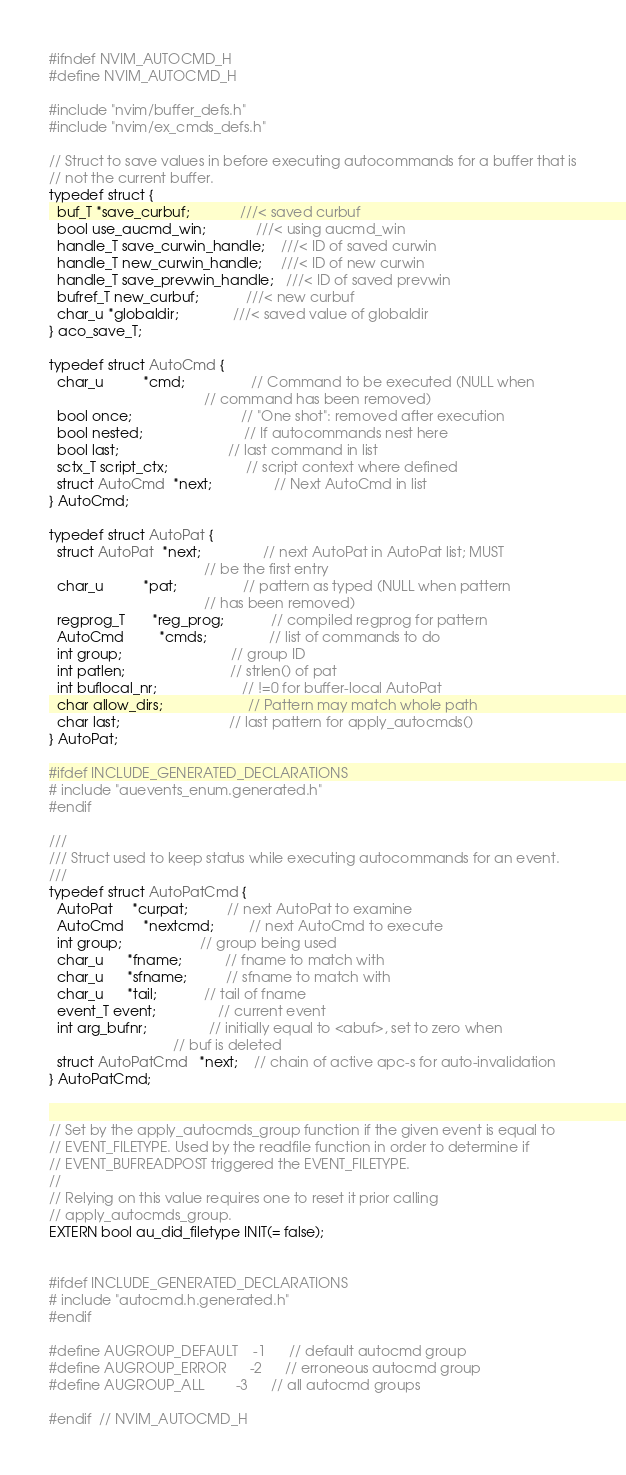<code> <loc_0><loc_0><loc_500><loc_500><_C_>#ifndef NVIM_AUTOCMD_H
#define NVIM_AUTOCMD_H

#include "nvim/buffer_defs.h"
#include "nvim/ex_cmds_defs.h"

// Struct to save values in before executing autocommands for a buffer that is
// not the current buffer.
typedef struct {
  buf_T *save_curbuf;             ///< saved curbuf
  bool use_aucmd_win;             ///< using aucmd_win
  handle_T save_curwin_handle;    ///< ID of saved curwin
  handle_T new_curwin_handle;     ///< ID of new curwin
  handle_T save_prevwin_handle;   ///< ID of saved prevwin
  bufref_T new_curbuf;            ///< new curbuf
  char_u *globaldir;              ///< saved value of globaldir
} aco_save_T;

typedef struct AutoCmd {
  char_u          *cmd;                 // Command to be executed (NULL when
                                        // command has been removed)
  bool once;                            // "One shot": removed after execution
  bool nested;                          // If autocommands nest here
  bool last;                            // last command in list
  sctx_T script_ctx;                    // script context where defined
  struct AutoCmd  *next;                // Next AutoCmd in list
} AutoCmd;

typedef struct AutoPat {
  struct AutoPat  *next;                // next AutoPat in AutoPat list; MUST
                                        // be the first entry
  char_u          *pat;                 // pattern as typed (NULL when pattern
                                        // has been removed)
  regprog_T       *reg_prog;            // compiled regprog for pattern
  AutoCmd         *cmds;                // list of commands to do
  int group;                            // group ID
  int patlen;                           // strlen() of pat
  int buflocal_nr;                      // !=0 for buffer-local AutoPat
  char allow_dirs;                      // Pattern may match whole path
  char last;                            // last pattern for apply_autocmds()
} AutoPat;

#ifdef INCLUDE_GENERATED_DECLARATIONS
# include "auevents_enum.generated.h"
#endif

///
/// Struct used to keep status while executing autocommands for an event.
///
typedef struct AutoPatCmd {
  AutoPat     *curpat;          // next AutoPat to examine
  AutoCmd     *nextcmd;         // next AutoCmd to execute
  int group;                    // group being used
  char_u      *fname;           // fname to match with
  char_u      *sfname;          // sfname to match with
  char_u      *tail;            // tail of fname
  event_T event;                // current event
  int arg_bufnr;                // initially equal to <abuf>, set to zero when
                                // buf is deleted
  struct AutoPatCmd   *next;    // chain of active apc-s for auto-invalidation
} AutoPatCmd;


// Set by the apply_autocmds_group function if the given event is equal to
// EVENT_FILETYPE. Used by the readfile function in order to determine if
// EVENT_BUFREADPOST triggered the EVENT_FILETYPE.
//
// Relying on this value requires one to reset it prior calling
// apply_autocmds_group.
EXTERN bool au_did_filetype INIT(= false);


#ifdef INCLUDE_GENERATED_DECLARATIONS
# include "autocmd.h.generated.h"
#endif

#define AUGROUP_DEFAULT    -1      // default autocmd group
#define AUGROUP_ERROR      -2      // erroneous autocmd group
#define AUGROUP_ALL        -3      // all autocmd groups

#endif  // NVIM_AUTOCMD_H
</code> 